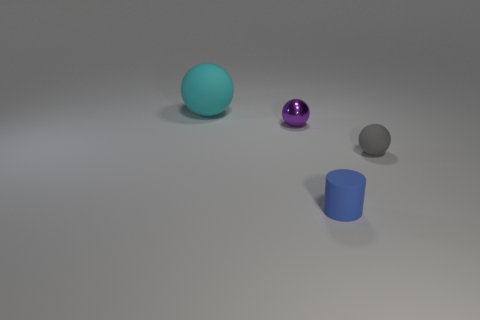Subtract all gray balls. How many balls are left? 2 Subtract 1 spheres. How many spheres are left? 2 Add 2 yellow things. How many objects exist? 6 Subtract all balls. How many objects are left? 1 Add 4 tiny objects. How many tiny objects exist? 7 Subtract 0 red cylinders. How many objects are left? 4 Subtract all blue balls. Subtract all purple cylinders. How many balls are left? 3 Subtract all large cyan balls. Subtract all big cyan rubber balls. How many objects are left? 2 Add 4 small gray things. How many small gray things are left? 5 